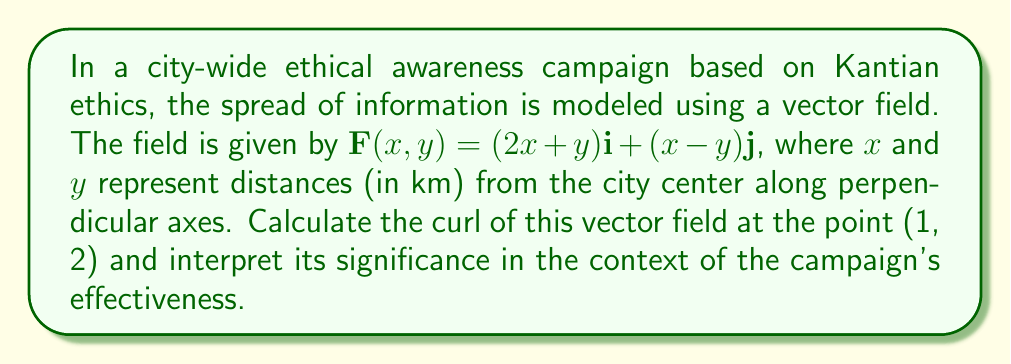Give your solution to this math problem. To solve this problem, we need to follow these steps:

1) The curl of a vector field $\mathbf{F}(x,y) = P(x,y)\mathbf{i} + Q(x,y)\mathbf{j}$ in two dimensions is given by:

   $$\text{curl }\mathbf{F} = \nabla \times \mathbf{F} = \left(\frac{\partial Q}{\partial x} - \frac{\partial P}{\partial y}\right)\mathbf{k}$$

2) In our case, $P(x,y) = 2x+y$ and $Q(x,y) = x-y$

3) We need to calculate $\frac{\partial Q}{\partial x}$ and $\frac{\partial P}{\partial y}$:

   $\frac{\partial Q}{\partial x} = \frac{\partial}{\partial x}(x-y) = 1$

   $\frac{\partial P}{\partial y} = \frac{\partial}{\partial y}(2x+y) = 1$

4) Now we can calculate the curl:

   $$\text{curl }\mathbf{F} = \left(\frac{\partial Q}{\partial x} - \frac{\partial P}{\partial y}\right)\mathbf{k} = (1 - 1)\mathbf{k} = 0\mathbf{k}$$

5) This result is constant for all points in the field, including (1, 2).

Interpretation: The curl of a vector field measures the tendency of the field to rotate around a point. A curl of zero indicates that the ethical awareness is spreading uniformly without any localized "spinning" or concentration. This suggests that the Kantian ethics campaign is disseminating information evenly across the city, aligning with the universal nature of Kantian ethics which emphasizes treating all individuals equally.
Answer: The curl of the vector field at point (1, 2) is $0\mathbf{k}$, indicating uniform spread of the ethical awareness campaign across the city. 